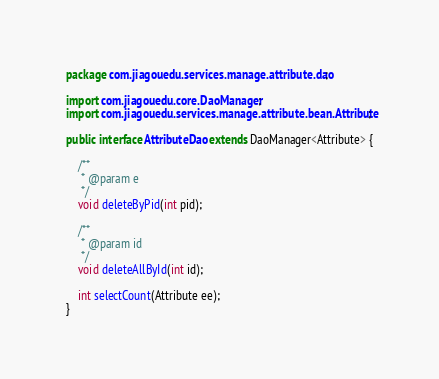<code> <loc_0><loc_0><loc_500><loc_500><_Java_>package com.jiagouedu.services.manage.attribute.dao;import com.jiagouedu.core.DaoManager;import com.jiagouedu.services.manage.attribute.bean.Attribute;public interface AttributeDao extends DaoManager<Attribute> {	/**	 * @param e	 */	void deleteByPid(int pid);	/**	 * @param id	 */	void deleteAllById(int id);	int selectCount(Attribute ee);}</code> 